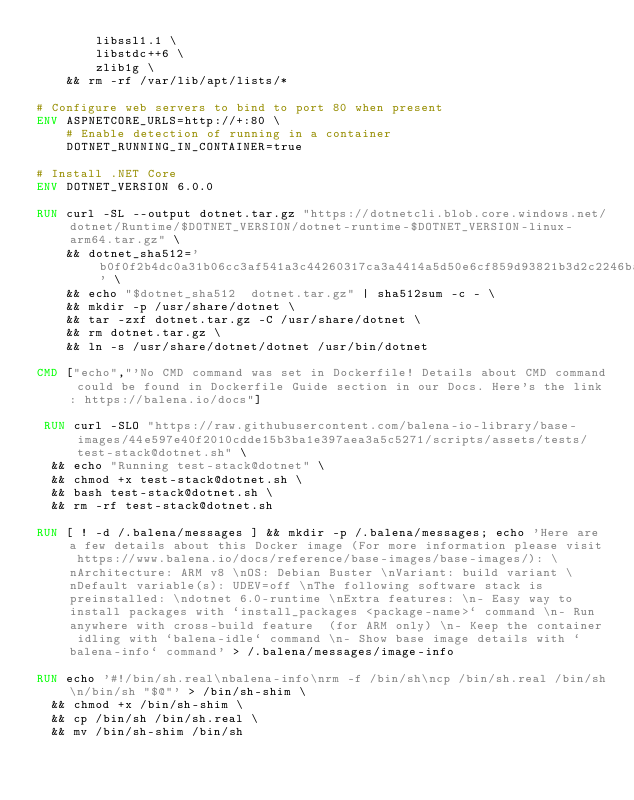Convert code to text. <code><loc_0><loc_0><loc_500><loc_500><_Dockerfile_>        libssl1.1 \
        libstdc++6 \
        zlib1g \
    && rm -rf /var/lib/apt/lists/*

# Configure web servers to bind to port 80 when present
ENV ASPNETCORE_URLS=http://+:80 \
    # Enable detection of running in a container
    DOTNET_RUNNING_IN_CONTAINER=true

# Install .NET Core
ENV DOTNET_VERSION 6.0.0

RUN curl -SL --output dotnet.tar.gz "https://dotnetcli.blob.core.windows.net/dotnet/Runtime/$DOTNET_VERSION/dotnet-runtime-$DOTNET_VERSION-linux-arm64.tar.gz" \
    && dotnet_sha512='b0f0f2b4dc0a31b06cc3af541a3c44260317ca3a4414a5d50e6cf859d93821b3d2c2246baec9f96004aeb1eb0e353631283b11cf3acc134d4694f0ed71c9503d' \
    && echo "$dotnet_sha512  dotnet.tar.gz" | sha512sum -c - \
    && mkdir -p /usr/share/dotnet \
    && tar -zxf dotnet.tar.gz -C /usr/share/dotnet \
    && rm dotnet.tar.gz \
    && ln -s /usr/share/dotnet/dotnet /usr/bin/dotnet

CMD ["echo","'No CMD command was set in Dockerfile! Details about CMD command could be found in Dockerfile Guide section in our Docs. Here's the link: https://balena.io/docs"]

 RUN curl -SLO "https://raw.githubusercontent.com/balena-io-library/base-images/44e597e40f2010cdde15b3ba1e397aea3a5c5271/scripts/assets/tests/test-stack@dotnet.sh" \
  && echo "Running test-stack@dotnet" \
  && chmod +x test-stack@dotnet.sh \
  && bash test-stack@dotnet.sh \
  && rm -rf test-stack@dotnet.sh 

RUN [ ! -d /.balena/messages ] && mkdir -p /.balena/messages; echo 'Here are a few details about this Docker image (For more information please visit https://www.balena.io/docs/reference/base-images/base-images/): \nArchitecture: ARM v8 \nOS: Debian Buster \nVariant: build variant \nDefault variable(s): UDEV=off \nThe following software stack is preinstalled: \ndotnet 6.0-runtime \nExtra features: \n- Easy way to install packages with `install_packages <package-name>` command \n- Run anywhere with cross-build feature  (for ARM only) \n- Keep the container idling with `balena-idle` command \n- Show base image details with `balena-info` command' > /.balena/messages/image-info

RUN echo '#!/bin/sh.real\nbalena-info\nrm -f /bin/sh\ncp /bin/sh.real /bin/sh\n/bin/sh "$@"' > /bin/sh-shim \
	&& chmod +x /bin/sh-shim \
	&& cp /bin/sh /bin/sh.real \
	&& mv /bin/sh-shim /bin/sh</code> 